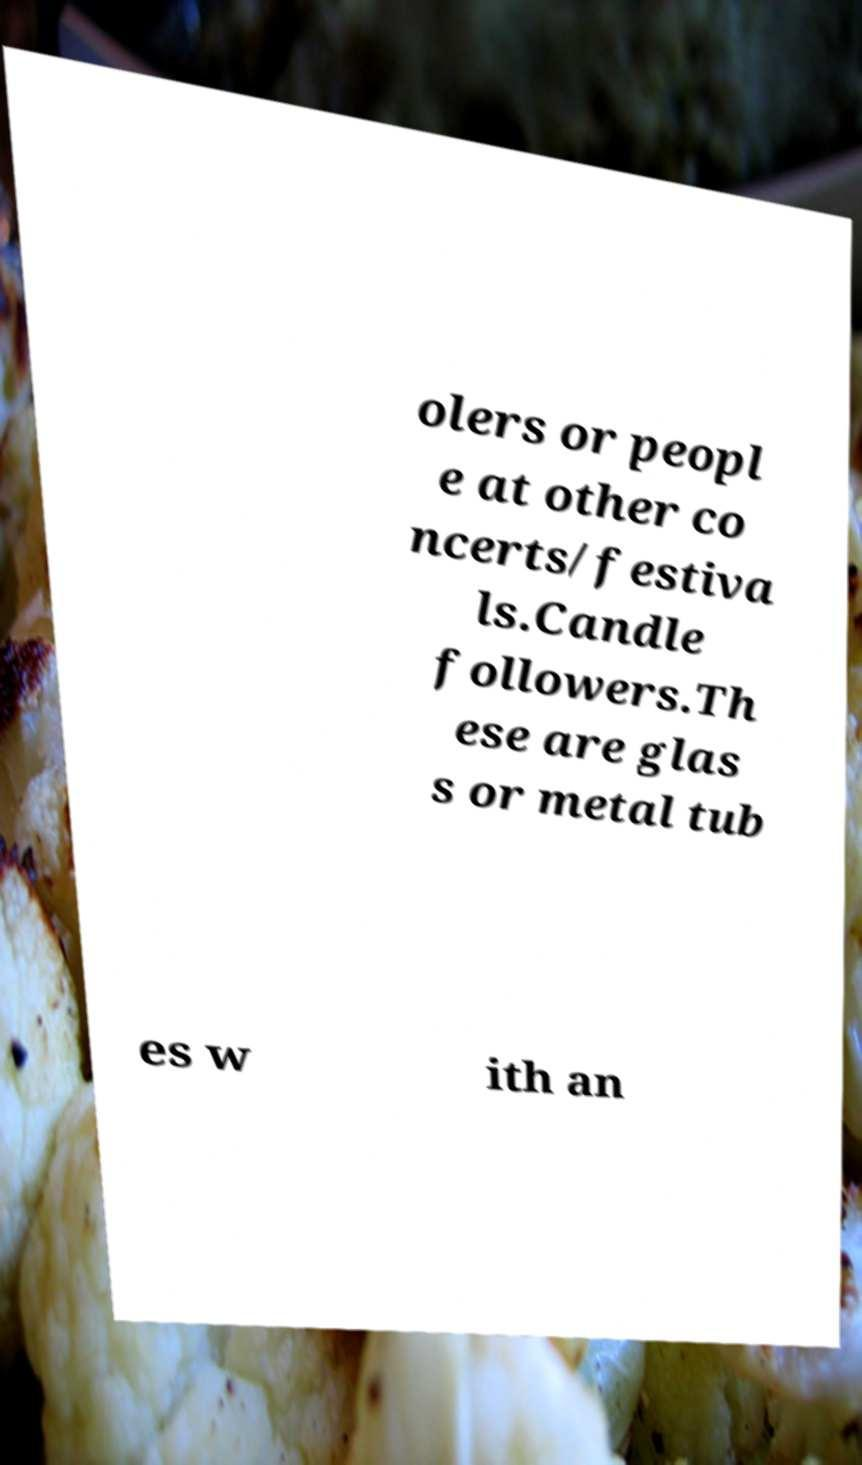Could you assist in decoding the text presented in this image and type it out clearly? olers or peopl e at other co ncerts/festiva ls.Candle followers.Th ese are glas s or metal tub es w ith an 